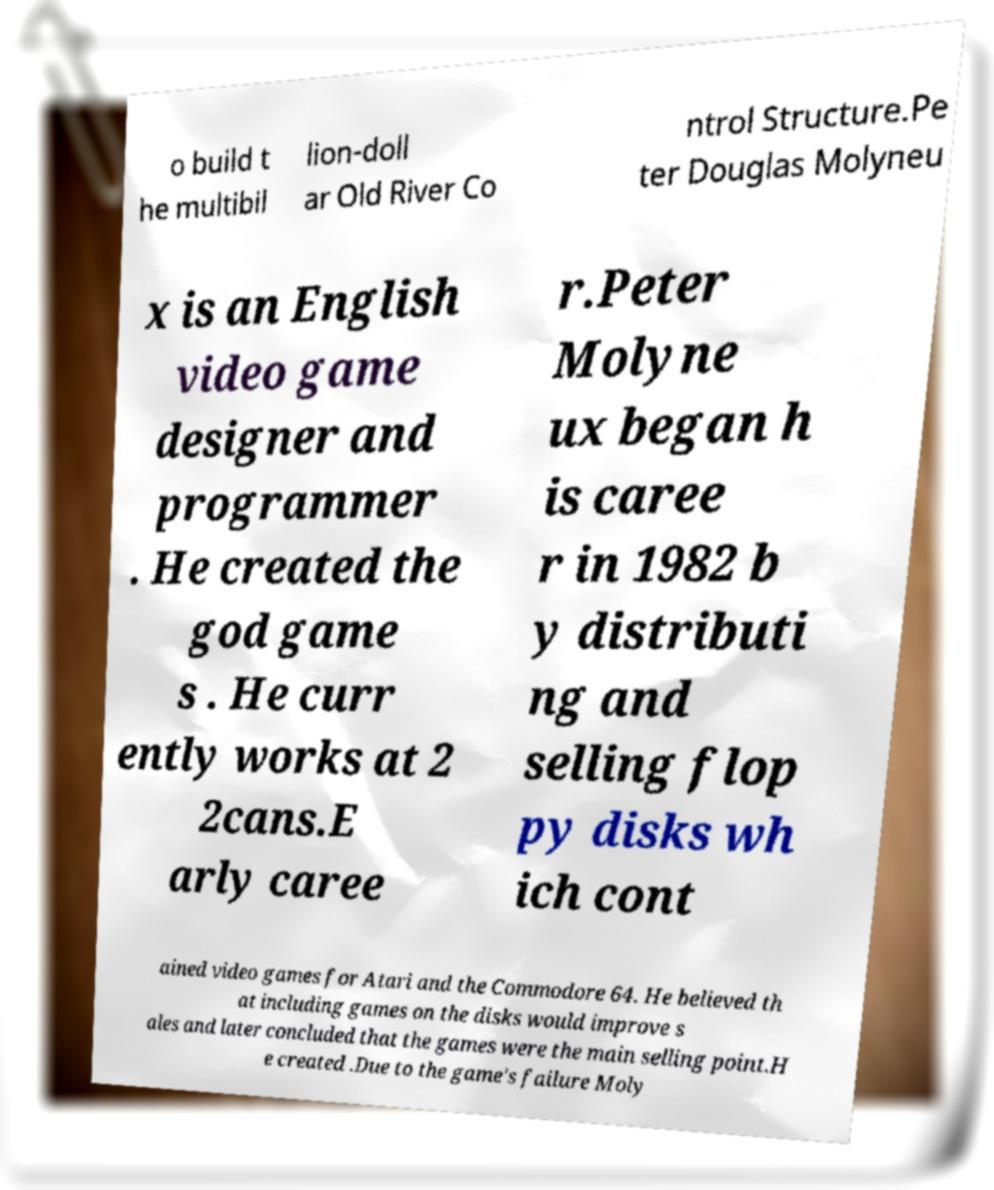Please identify and transcribe the text found in this image. o build t he multibil lion-doll ar Old River Co ntrol Structure.Pe ter Douglas Molyneu x is an English video game designer and programmer . He created the god game s . He curr ently works at 2 2cans.E arly caree r.Peter Molyne ux began h is caree r in 1982 b y distributi ng and selling flop py disks wh ich cont ained video games for Atari and the Commodore 64. He believed th at including games on the disks would improve s ales and later concluded that the games were the main selling point.H e created .Due to the game's failure Moly 